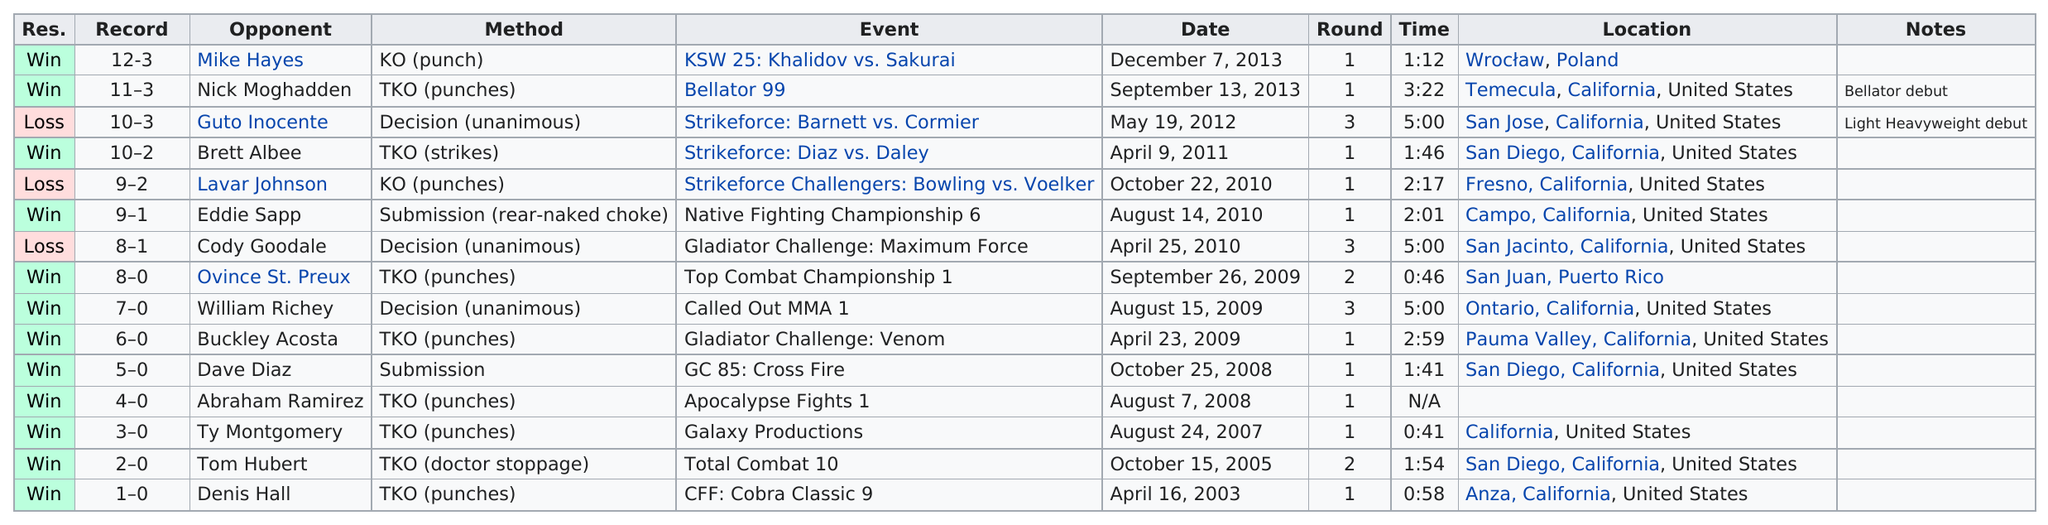List a handful of essential elements in this visual. The total number of submission victories is 2. Zwicker faced Hall on October 15th, 2005, and before him, Hall was faced by Denis. In addition to the loss to Cody Goodale, several other losses occurred, including Guto Inocente and Lavar Johnson. In 2013, Zwicker, Hayes, and Moghadden were seen together by an unidentified person. Cody Goodale lost to the boxer in a unanimous decision after a total of 3 rounds of intense fighting. 